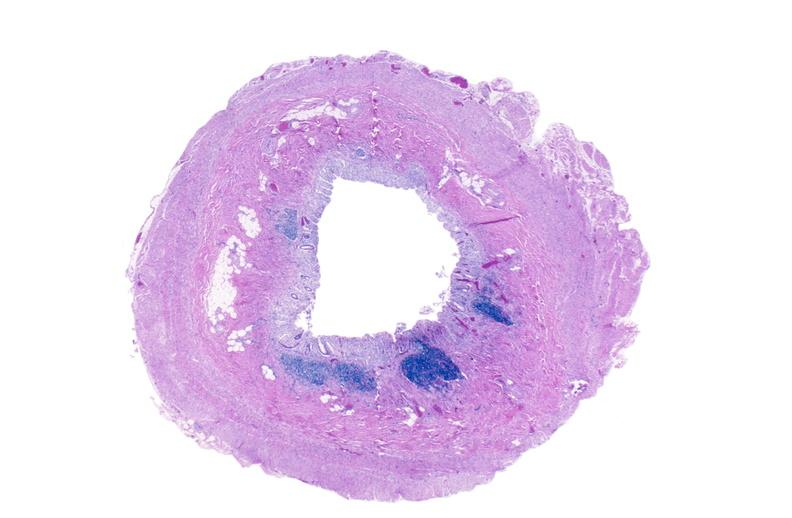where is this from?
Answer the question using a single word or phrase. Gastrointestinal system 